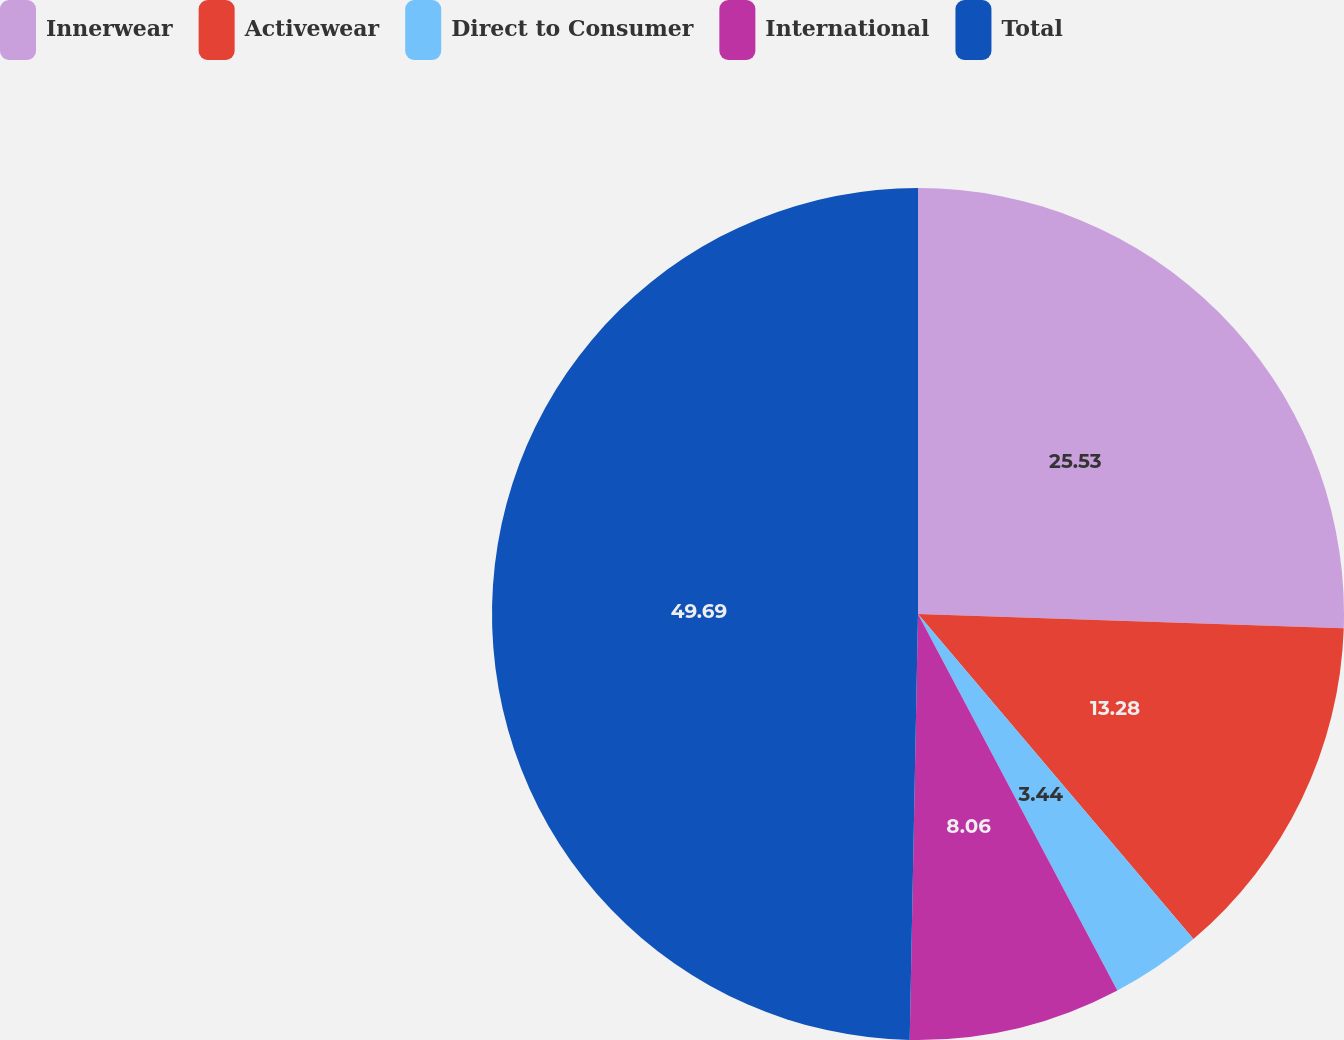Convert chart. <chart><loc_0><loc_0><loc_500><loc_500><pie_chart><fcel>Innerwear<fcel>Activewear<fcel>Direct to Consumer<fcel>International<fcel>Total<nl><fcel>25.53%<fcel>13.28%<fcel>3.44%<fcel>8.06%<fcel>49.69%<nl></chart> 